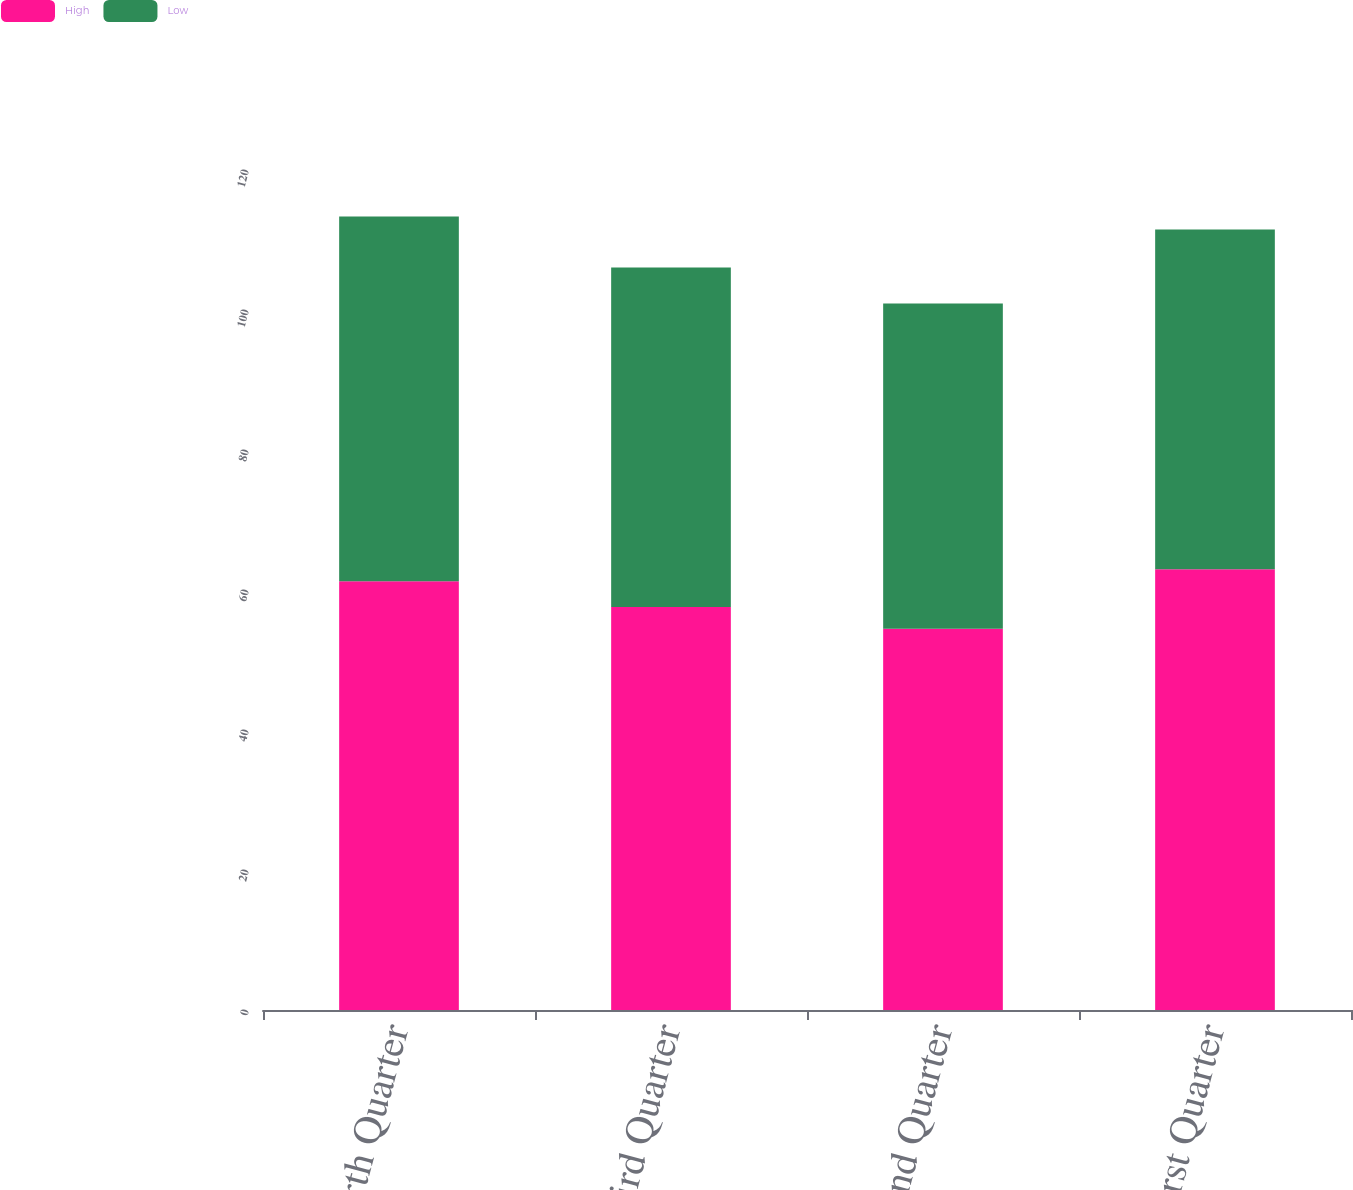Convert chart. <chart><loc_0><loc_0><loc_500><loc_500><stacked_bar_chart><ecel><fcel>Fourth Quarter<fcel>Third Quarter<fcel>Second Quarter<fcel>First Quarter<nl><fcel>High<fcel>61.25<fcel>57.57<fcel>54.47<fcel>62.96<nl><fcel>Low<fcel>52.1<fcel>48.5<fcel>46.45<fcel>48.55<nl></chart> 